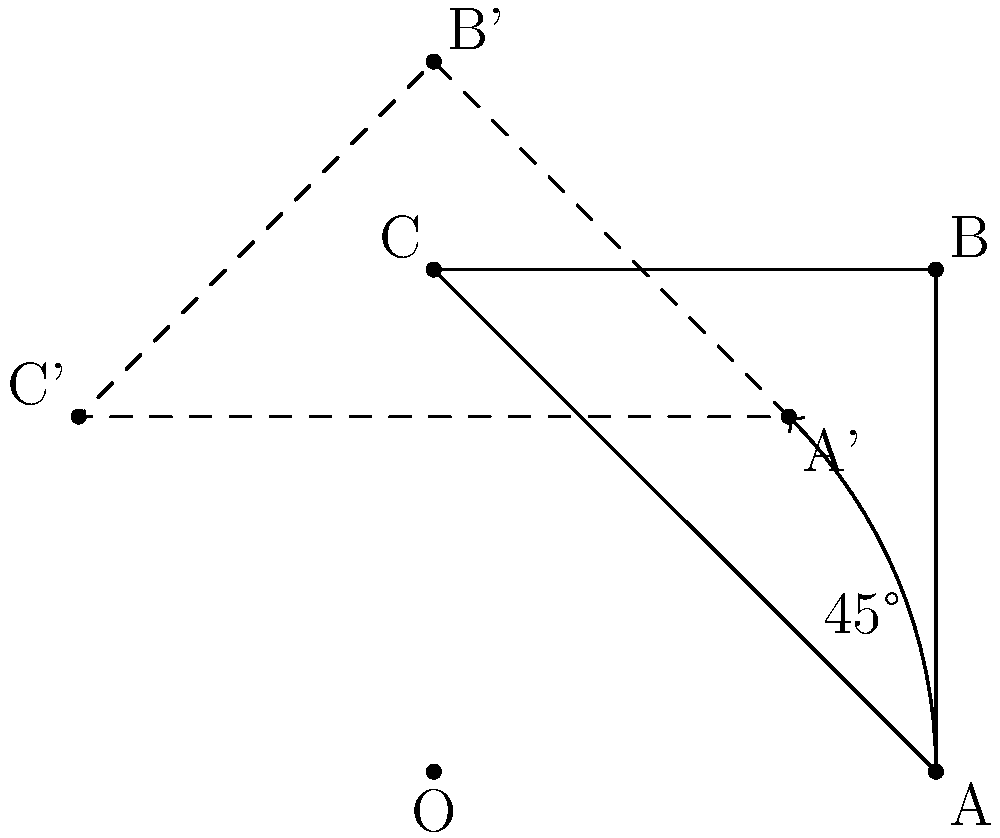In the context of internationalization (i18n) for a European mapping application, you need to implement a feature that rotates map elements. Given an equilateral triangle ABC with side length 2 units, centered at the origin O(0,0), what are the coordinates of point A' after rotating the triangle 45° counterclockwise around O? To find the coordinates of A' after rotation, we can follow these steps:

1. Identify the initial coordinates of A:
   A is on the x-axis, 2 units from the origin, so A(2,0).

2. Use the rotation matrix for a 45° counterclockwise rotation:
   $$R = \begin{bmatrix} 
   \cos 45° & -\sin 45° \\
   \sin 45° & \cos 45°
   \end{bmatrix}$$

3. Simplify the rotation matrix:
   $$R = \begin{bmatrix} 
   \frac{\sqrt{2}}{2} & -\frac{\sqrt{2}}{2} \\
   \frac{\sqrt{2}}{2} & \frac{\sqrt{2}}{2}
   \end{bmatrix}$$

4. Apply the rotation matrix to the coordinates of A:
   $$A' = R \cdot A = \begin{bmatrix} 
   \frac{\sqrt{2}}{2} & -\frac{\sqrt{2}}{2} \\
   \frac{\sqrt{2}}{2} & \frac{\sqrt{2}}{2}
   \end{bmatrix} \cdot \begin{bmatrix} 
   2 \\
   0
   \end{bmatrix}$$

5. Multiply the matrices:
   $$A' = \begin{bmatrix} 
   2 \cdot \frac{\sqrt{2}}{2} \\
   2 \cdot \frac{\sqrt{2}}{2}
   \end{bmatrix} = \begin{bmatrix} 
   \sqrt{2} \\
   \sqrt{2}
   \end{bmatrix}$$

Therefore, the coordinates of A' after rotation are $(\sqrt{2}, \sqrt{2})$.
Answer: $(\sqrt{2}, \sqrt{2})$ 